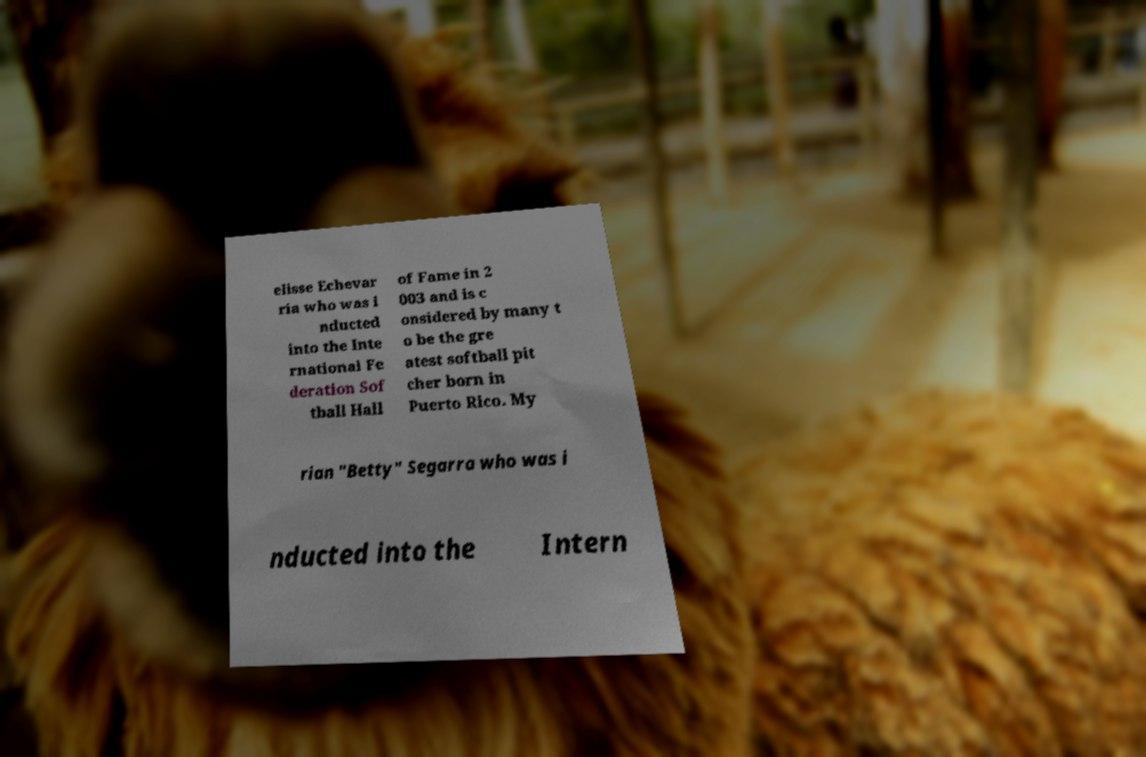Can you read and provide the text displayed in the image?This photo seems to have some interesting text. Can you extract and type it out for me? elisse Echevar ria who was i nducted into the Inte rnational Fe deration Sof tball Hall of Fame in 2 003 and is c onsidered by many t o be the gre atest softball pit cher born in Puerto Rico. My rian "Betty" Segarra who was i nducted into the Intern 